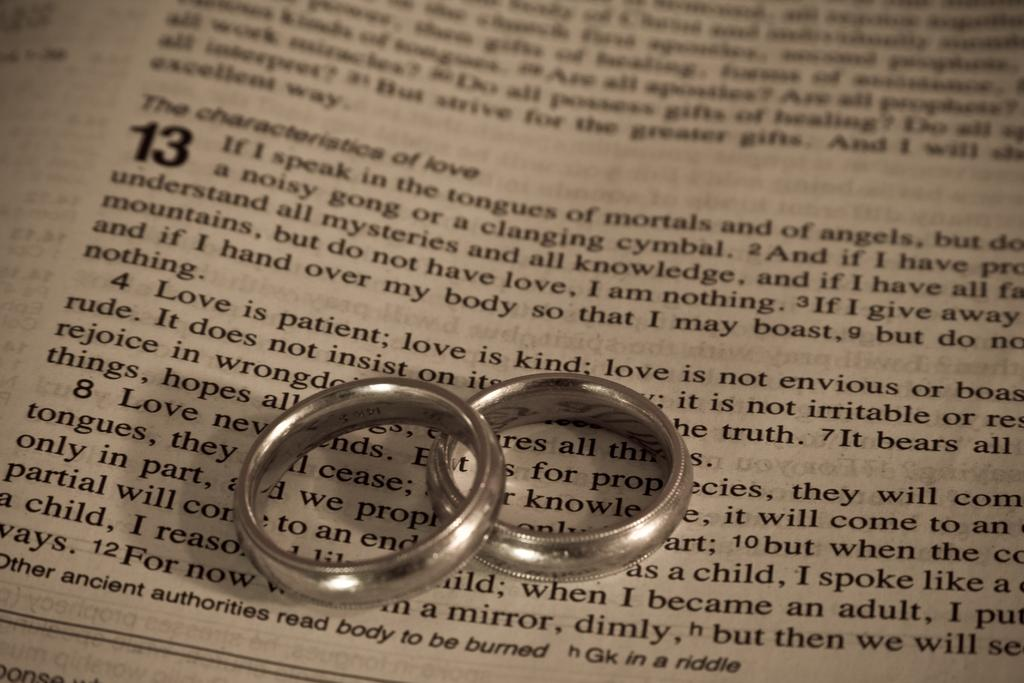Provide a one-sentence caption for the provided image. Two rings on top of a book where the paragraphs start with "The characteristics of love". 